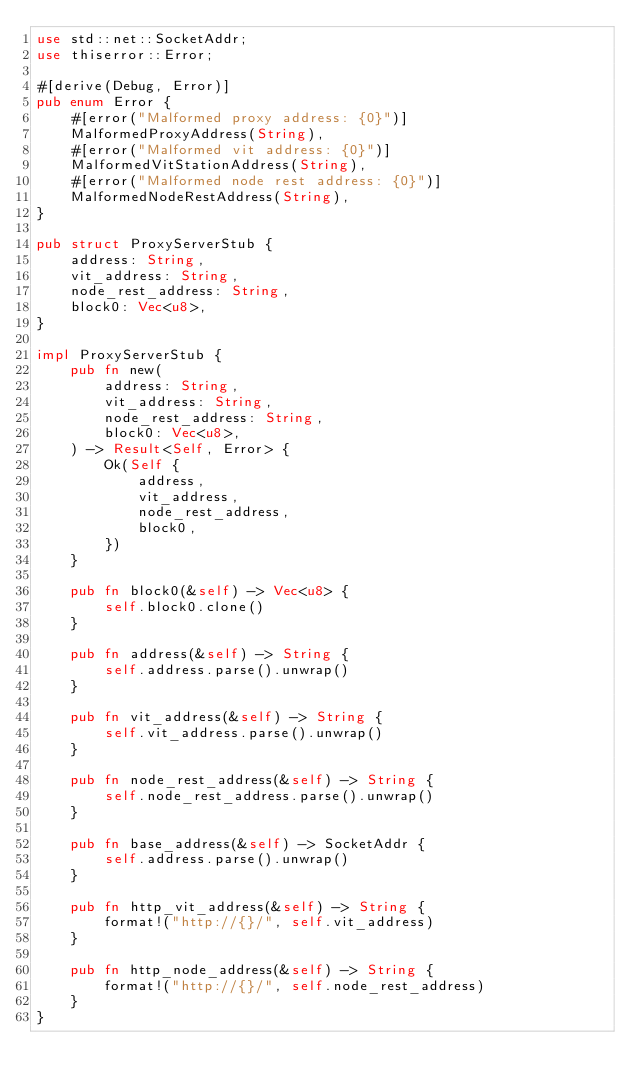Convert code to text. <code><loc_0><loc_0><loc_500><loc_500><_Rust_>use std::net::SocketAddr;
use thiserror::Error;

#[derive(Debug, Error)]
pub enum Error {
    #[error("Malformed proxy address: {0}")]
    MalformedProxyAddress(String),
    #[error("Malformed vit address: {0}")]
    MalformedVitStationAddress(String),
    #[error("Malformed node rest address: {0}")]
    MalformedNodeRestAddress(String),
}

pub struct ProxyServerStub {
    address: String,
    vit_address: String,
    node_rest_address: String,
    block0: Vec<u8>,
}

impl ProxyServerStub {
    pub fn new(
        address: String,
        vit_address: String,
        node_rest_address: String,
        block0: Vec<u8>,
    ) -> Result<Self, Error> {
        Ok(Self {
            address,
            vit_address,
            node_rest_address,
            block0,
        })
    }

    pub fn block0(&self) -> Vec<u8> {
        self.block0.clone()
    }

    pub fn address(&self) -> String {
        self.address.parse().unwrap()
    }

    pub fn vit_address(&self) -> String {
        self.vit_address.parse().unwrap()
    }

    pub fn node_rest_address(&self) -> String {
        self.node_rest_address.parse().unwrap()
    }

    pub fn base_address(&self) -> SocketAddr {
        self.address.parse().unwrap()
    }

    pub fn http_vit_address(&self) -> String {
        format!("http://{}/", self.vit_address)
    }

    pub fn http_node_address(&self) -> String {
        format!("http://{}/", self.node_rest_address)
    }
}
</code> 